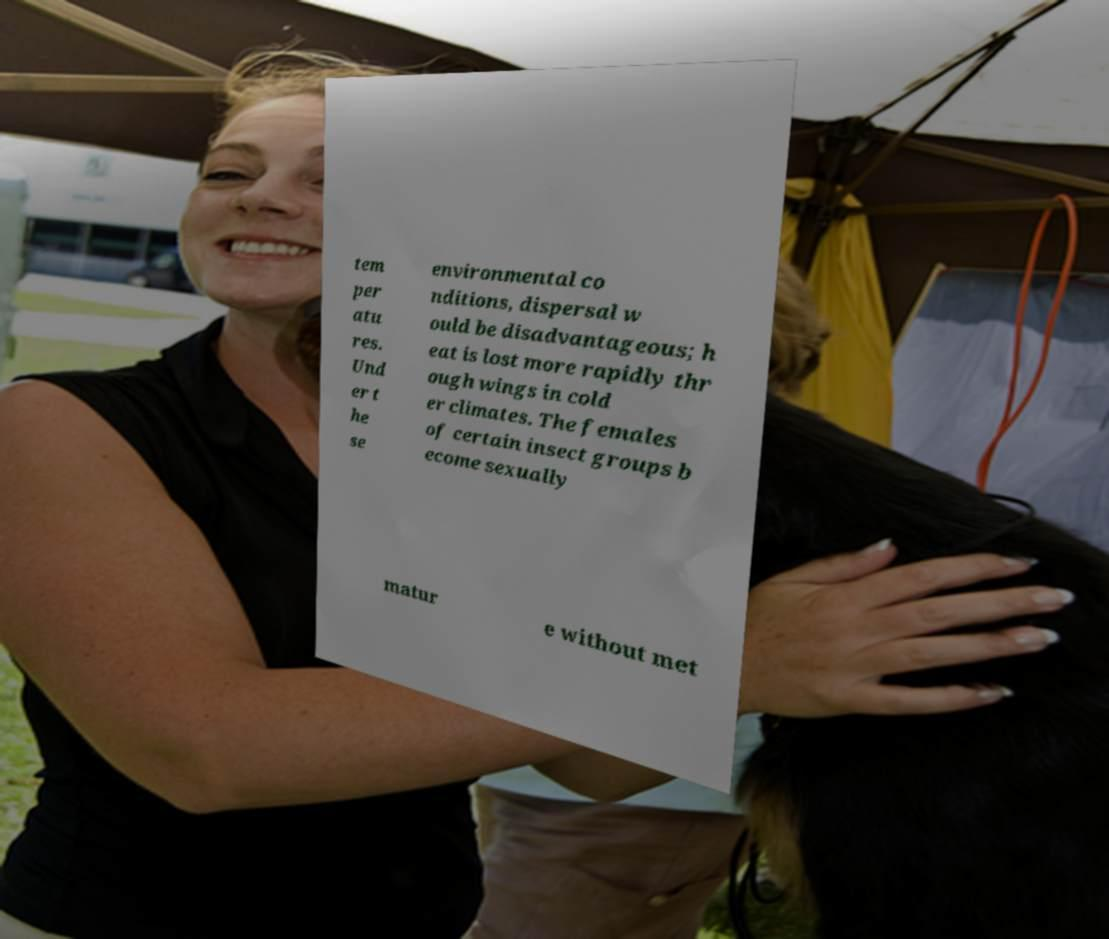Please read and relay the text visible in this image. What does it say? tem per atu res. Und er t he se environmental co nditions, dispersal w ould be disadvantageous; h eat is lost more rapidly thr ough wings in cold er climates. The females of certain insect groups b ecome sexually matur e without met 